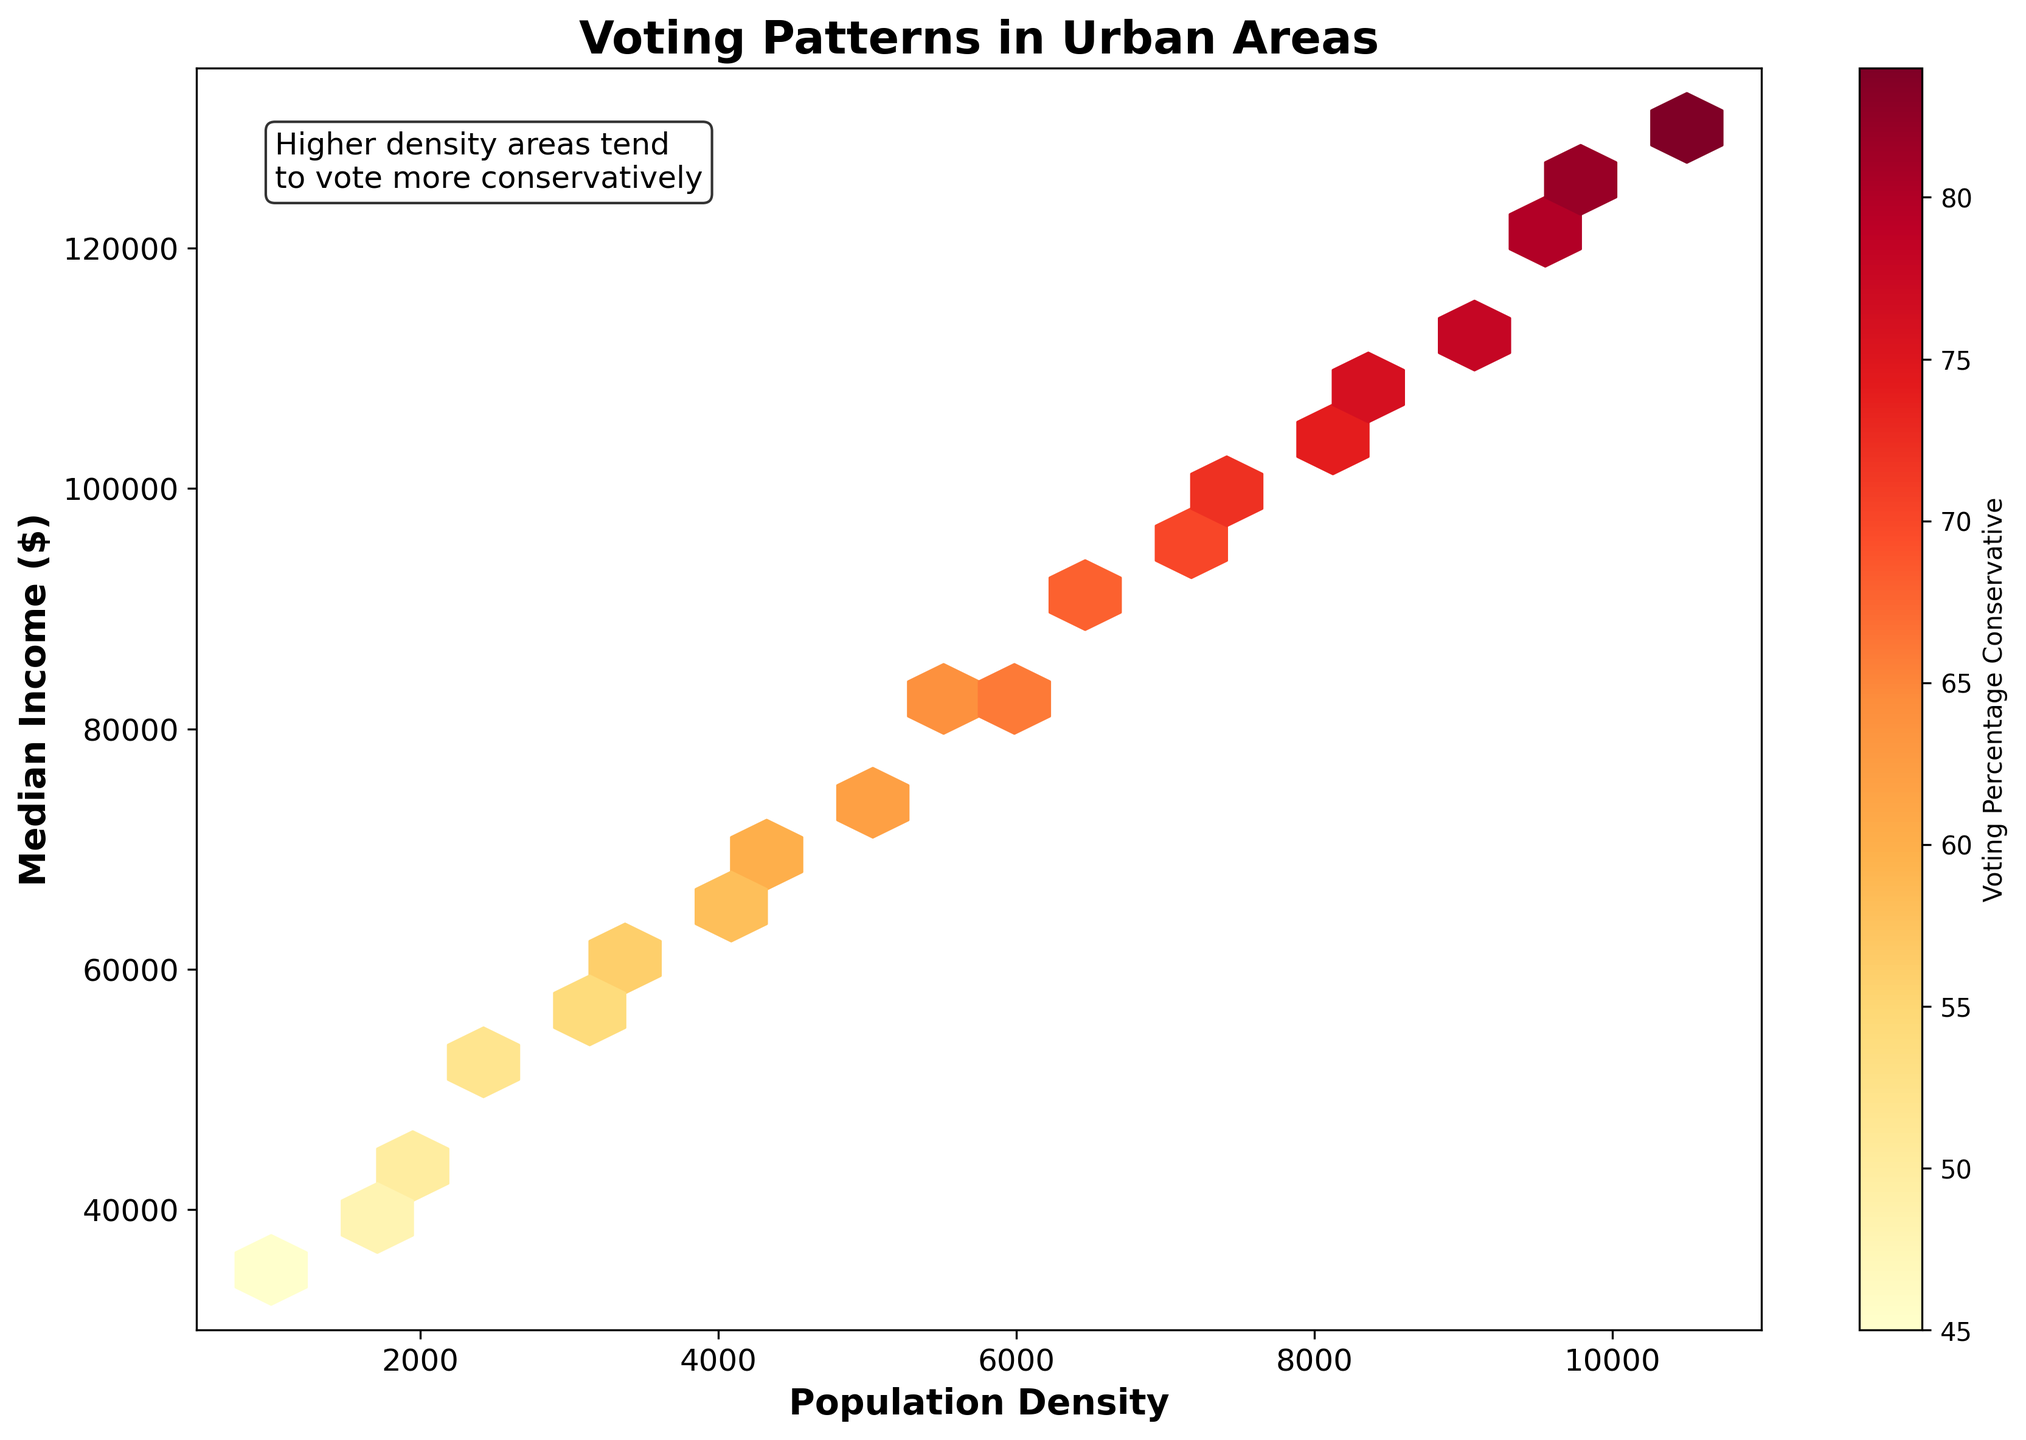What is the title of the figure? It is located at the top of the figure, usually in a large and bold font.
Answer: Voting Patterns in Urban Areas Which axis represents the Median Income? Typically, axis labels are placed beside or below the respective axis. In this figure, the axis label next to the vertical axis says "Median Income ($)."
Answer: The vertical axis (y-axis) What is the range of the Population Density shown on the figure? The x-axis represents Population Density, and its range is shown from the minimum to the maximum tick marks on this axis.
Answer: 500 to 11000 Where are the highest Voting Percentages Conservative typically observed in terms of Median Income? The color gradient on the plot indicates that darker colors correspond to higher voting percentages, and these occur in areas with higher median incomes.
Answer: Highest Voting Percentages Conservative are typically observed in areas with higher Median Income Which area has more diversity concerning Voting Percentage Conservative, low or high population density? The density of hexbin cells can illustrate diversity; more variation in colors implies more diversity. Areas with low population density have fewer and more uniformly colored cells compared to high population density areas.
Answer: High population density What can you infer about the relationship between Population Density and Median Income? By observing the spread of hexbin cells, there appears to be a positive correlation. As population density increases, the median income also tends to increase.
Answer: Positive correlation What pattern is observed regarding Median Income when the Population Density doubles from 5000 to 10000? By looking at the figure, the median income increases as population density moves from 5000 to 10000. The hexbin cells in this range transition from lighter to darker shades, indicating a higher income.
Answer: Median income increases Can you identify a trend between Population Density and Voting Percentage Conservative? The color gradient indicates this trend. As you move right along the x-axis (higher population density), the cells become darker, indicating increasing Voting Percentage Conservative.
Answer: Voting Percentage Conservative increases with Population Density Compare the Voting Percentage Conservative at a Population Density of 2000 and 8000 with a Median Income of 45000 and 105000, respectively. At Population Density of 2000, the Voting Percentage Conservative is around 50. At Population Density of 8000, it is around 74. This can be inferred from the cell colors and the associated values.
Answer: 50 at 2000, 74 at 8000 What does the text annotation "Higher density areas tend to vote more conservatively" suggest about the relationship observed in the hexbin plot? This annotation explicitly points to a key insight derived from the plot: that higher population density areas shown by the x-axis correlate with increased conservative voting percentages indicated by color intensity.
Answer: Higher density areas tend to vote more conservatively 